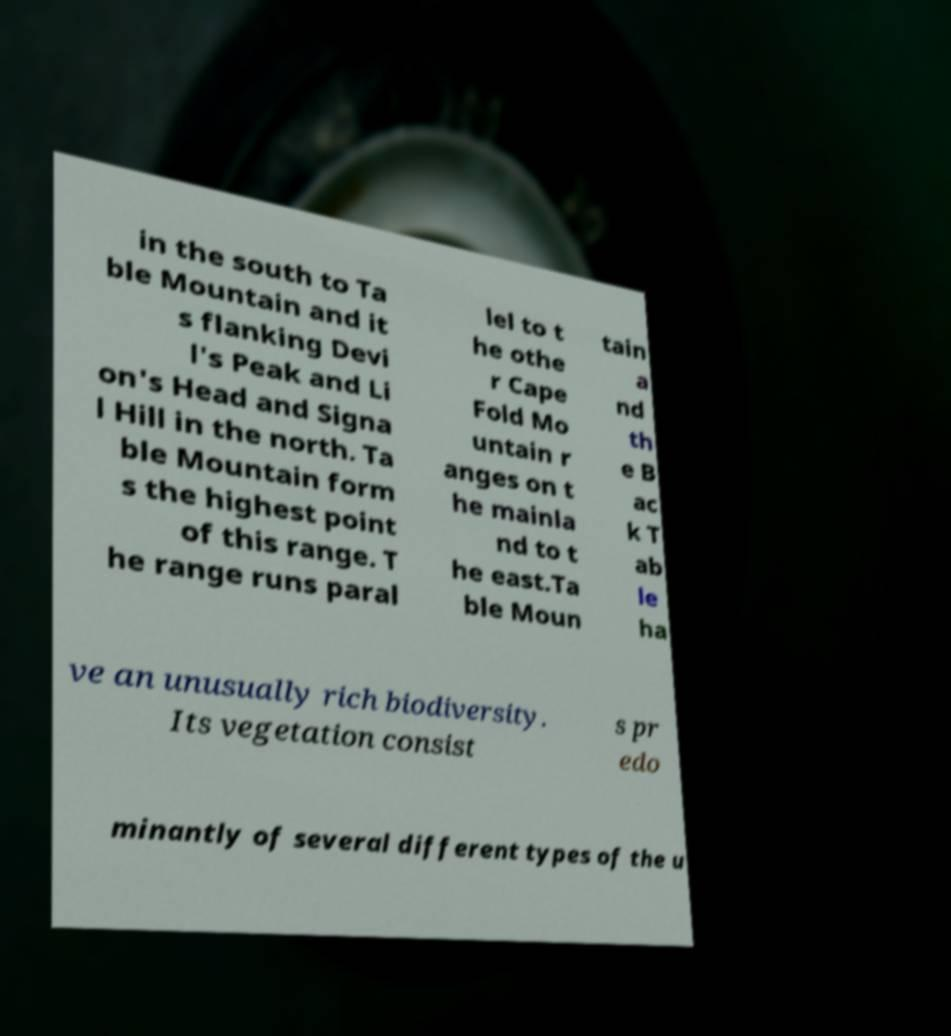Could you assist in decoding the text presented in this image and type it out clearly? in the south to Ta ble Mountain and it s flanking Devi l's Peak and Li on's Head and Signa l Hill in the north. Ta ble Mountain form s the highest point of this range. T he range runs paral lel to t he othe r Cape Fold Mo untain r anges on t he mainla nd to t he east.Ta ble Moun tain a nd th e B ac k T ab le ha ve an unusually rich biodiversity. Its vegetation consist s pr edo minantly of several different types of the u 